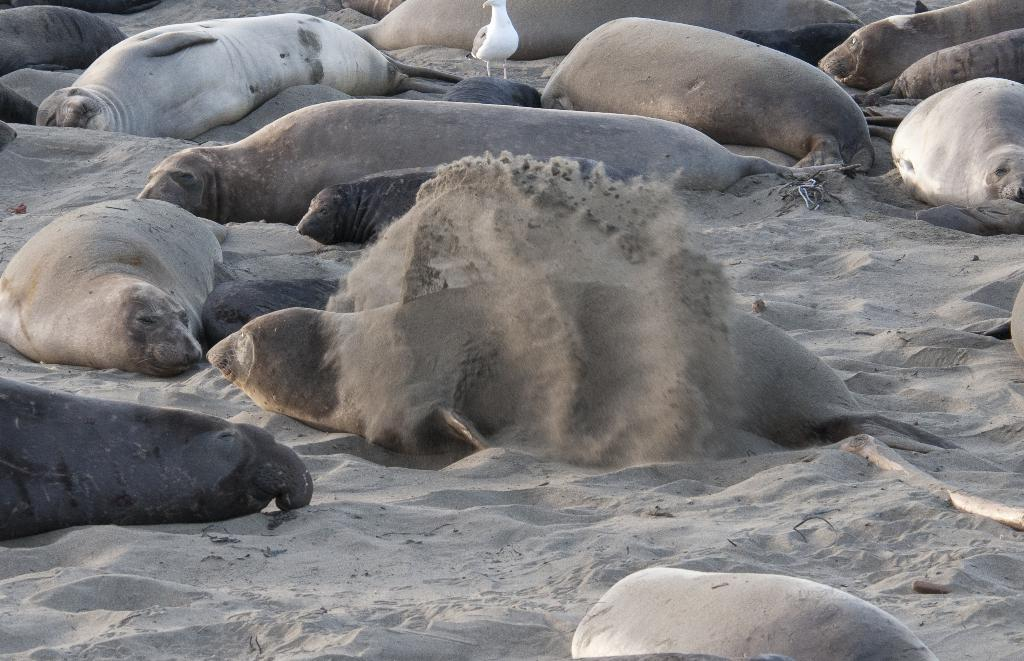What type of animals can be seen in the image? There are seals in the image. Are there any other animals or creatures present in the image? Yes, there is a bird in the image. What type of border can be seen around the image? There is no border visible around the image; the focus is on the seals and the bird. What is the measure of the bird's wingspan in the image? The provided facts do not include any information about the bird's wingspan, so it cannot be determined from the image. 